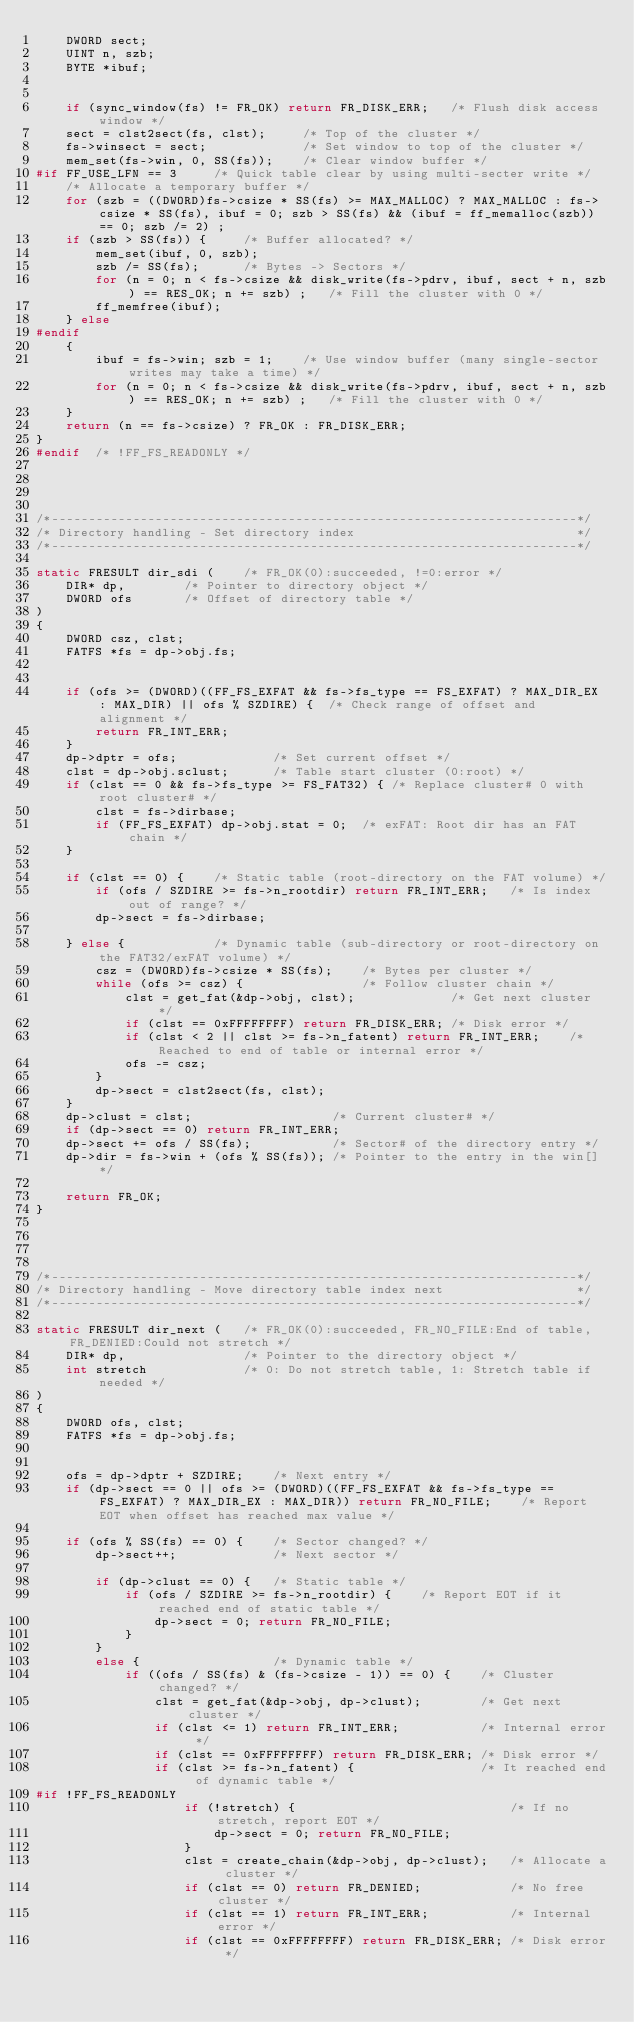<code> <loc_0><loc_0><loc_500><loc_500><_C_>	DWORD sect;
	UINT n, szb;
	BYTE *ibuf;


	if (sync_window(fs) != FR_OK) return FR_DISK_ERR;	/* Flush disk access window */
	sect = clst2sect(fs, clst);		/* Top of the cluster */
	fs->winsect = sect;				/* Set window to top of the cluster */
	mem_set(fs->win, 0, SS(fs));	/* Clear window buffer */
#if FF_USE_LFN == 3		/* Quick table clear by using multi-secter write */
	/* Allocate a temporary buffer */
	for (szb = ((DWORD)fs->csize * SS(fs) >= MAX_MALLOC) ? MAX_MALLOC : fs->csize * SS(fs), ibuf = 0; szb > SS(fs) && (ibuf = ff_memalloc(szb)) == 0; szb /= 2) ;
	if (szb > SS(fs)) {		/* Buffer allocated? */
		mem_set(ibuf, 0, szb);
		szb /= SS(fs);		/* Bytes -> Sectors */
		for (n = 0; n < fs->csize && disk_write(fs->pdrv, ibuf, sect + n, szb) == RES_OK; n += szb) ;	/* Fill the cluster with 0 */
		ff_memfree(ibuf);
	} else
#endif
	{
		ibuf = fs->win; szb = 1;	/* Use window buffer (many single-sector writes may take a time) */
		for (n = 0; n < fs->csize && disk_write(fs->pdrv, ibuf, sect + n, szb) == RES_OK; n += szb) ;	/* Fill the cluster with 0 */
	}
	return (n == fs->csize) ? FR_OK : FR_DISK_ERR;
}
#endif	/* !FF_FS_READONLY */




/*-----------------------------------------------------------------------*/
/* Directory handling - Set directory index                              */
/*-----------------------------------------------------------------------*/

static FRESULT dir_sdi (	/* FR_OK(0):succeeded, !=0:error */
	DIR* dp,		/* Pointer to directory object */
	DWORD ofs		/* Offset of directory table */
)
{
	DWORD csz, clst;
	FATFS *fs = dp->obj.fs;


	if (ofs >= (DWORD)((FF_FS_EXFAT && fs->fs_type == FS_EXFAT) ? MAX_DIR_EX : MAX_DIR) || ofs % SZDIRE) {	/* Check range of offset and alignment */
		return FR_INT_ERR;
	}
	dp->dptr = ofs;				/* Set current offset */
	clst = dp->obj.sclust;		/* Table start cluster (0:root) */
	if (clst == 0 && fs->fs_type >= FS_FAT32) {	/* Replace cluster# 0 with root cluster# */
		clst = fs->dirbase;
		if (FF_FS_EXFAT) dp->obj.stat = 0;	/* exFAT: Root dir has an FAT chain */
	}

	if (clst == 0) {	/* Static table (root-directory on the FAT volume) */
		if (ofs / SZDIRE >= fs->n_rootdir) return FR_INT_ERR;	/* Is index out of range? */
		dp->sect = fs->dirbase;

	} else {			/* Dynamic table (sub-directory or root-directory on the FAT32/exFAT volume) */
		csz = (DWORD)fs->csize * SS(fs);	/* Bytes per cluster */
		while (ofs >= csz) {				/* Follow cluster chain */
			clst = get_fat(&dp->obj, clst);				/* Get next cluster */
			if (clst == 0xFFFFFFFF) return FR_DISK_ERR;	/* Disk error */
			if (clst < 2 || clst >= fs->n_fatent) return FR_INT_ERR;	/* Reached to end of table or internal error */
			ofs -= csz;
		}
		dp->sect = clst2sect(fs, clst);
	}
	dp->clust = clst;					/* Current cluster# */
	if (dp->sect == 0) return FR_INT_ERR;
	dp->sect += ofs / SS(fs);			/* Sector# of the directory entry */
	dp->dir = fs->win + (ofs % SS(fs));	/* Pointer to the entry in the win[] */

	return FR_OK;
}




/*-----------------------------------------------------------------------*/
/* Directory handling - Move directory table index next                  */
/*-----------------------------------------------------------------------*/

static FRESULT dir_next (	/* FR_OK(0):succeeded, FR_NO_FILE:End of table, FR_DENIED:Could not stretch */
	DIR* dp,				/* Pointer to the directory object */
	int stretch				/* 0: Do not stretch table, 1: Stretch table if needed */
)
{
	DWORD ofs, clst;
	FATFS *fs = dp->obj.fs;


	ofs = dp->dptr + SZDIRE;	/* Next entry */
	if (dp->sect == 0 || ofs >= (DWORD)((FF_FS_EXFAT && fs->fs_type == FS_EXFAT) ? MAX_DIR_EX : MAX_DIR)) return FR_NO_FILE;	/* Report EOT when offset has reached max value */

	if (ofs % SS(fs) == 0) {	/* Sector changed? */
		dp->sect++;				/* Next sector */

		if (dp->clust == 0) {	/* Static table */
			if (ofs / SZDIRE >= fs->n_rootdir) {	/* Report EOT if it reached end of static table */
				dp->sect = 0; return FR_NO_FILE;
			}
		}
		else {					/* Dynamic table */
			if ((ofs / SS(fs) & (fs->csize - 1)) == 0) {	/* Cluster changed? */
				clst = get_fat(&dp->obj, dp->clust);		/* Get next cluster */
				if (clst <= 1) return FR_INT_ERR;			/* Internal error */
				if (clst == 0xFFFFFFFF) return FR_DISK_ERR;	/* Disk error */
				if (clst >= fs->n_fatent) {					/* It reached end of dynamic table */
#if !FF_FS_READONLY
					if (!stretch) {								/* If no stretch, report EOT */
						dp->sect = 0; return FR_NO_FILE;
					}
					clst = create_chain(&dp->obj, dp->clust);	/* Allocate a cluster */
					if (clst == 0) return FR_DENIED;			/* No free cluster */
					if (clst == 1) return FR_INT_ERR;			/* Internal error */
					if (clst == 0xFFFFFFFF) return FR_DISK_ERR;	/* Disk error */</code> 